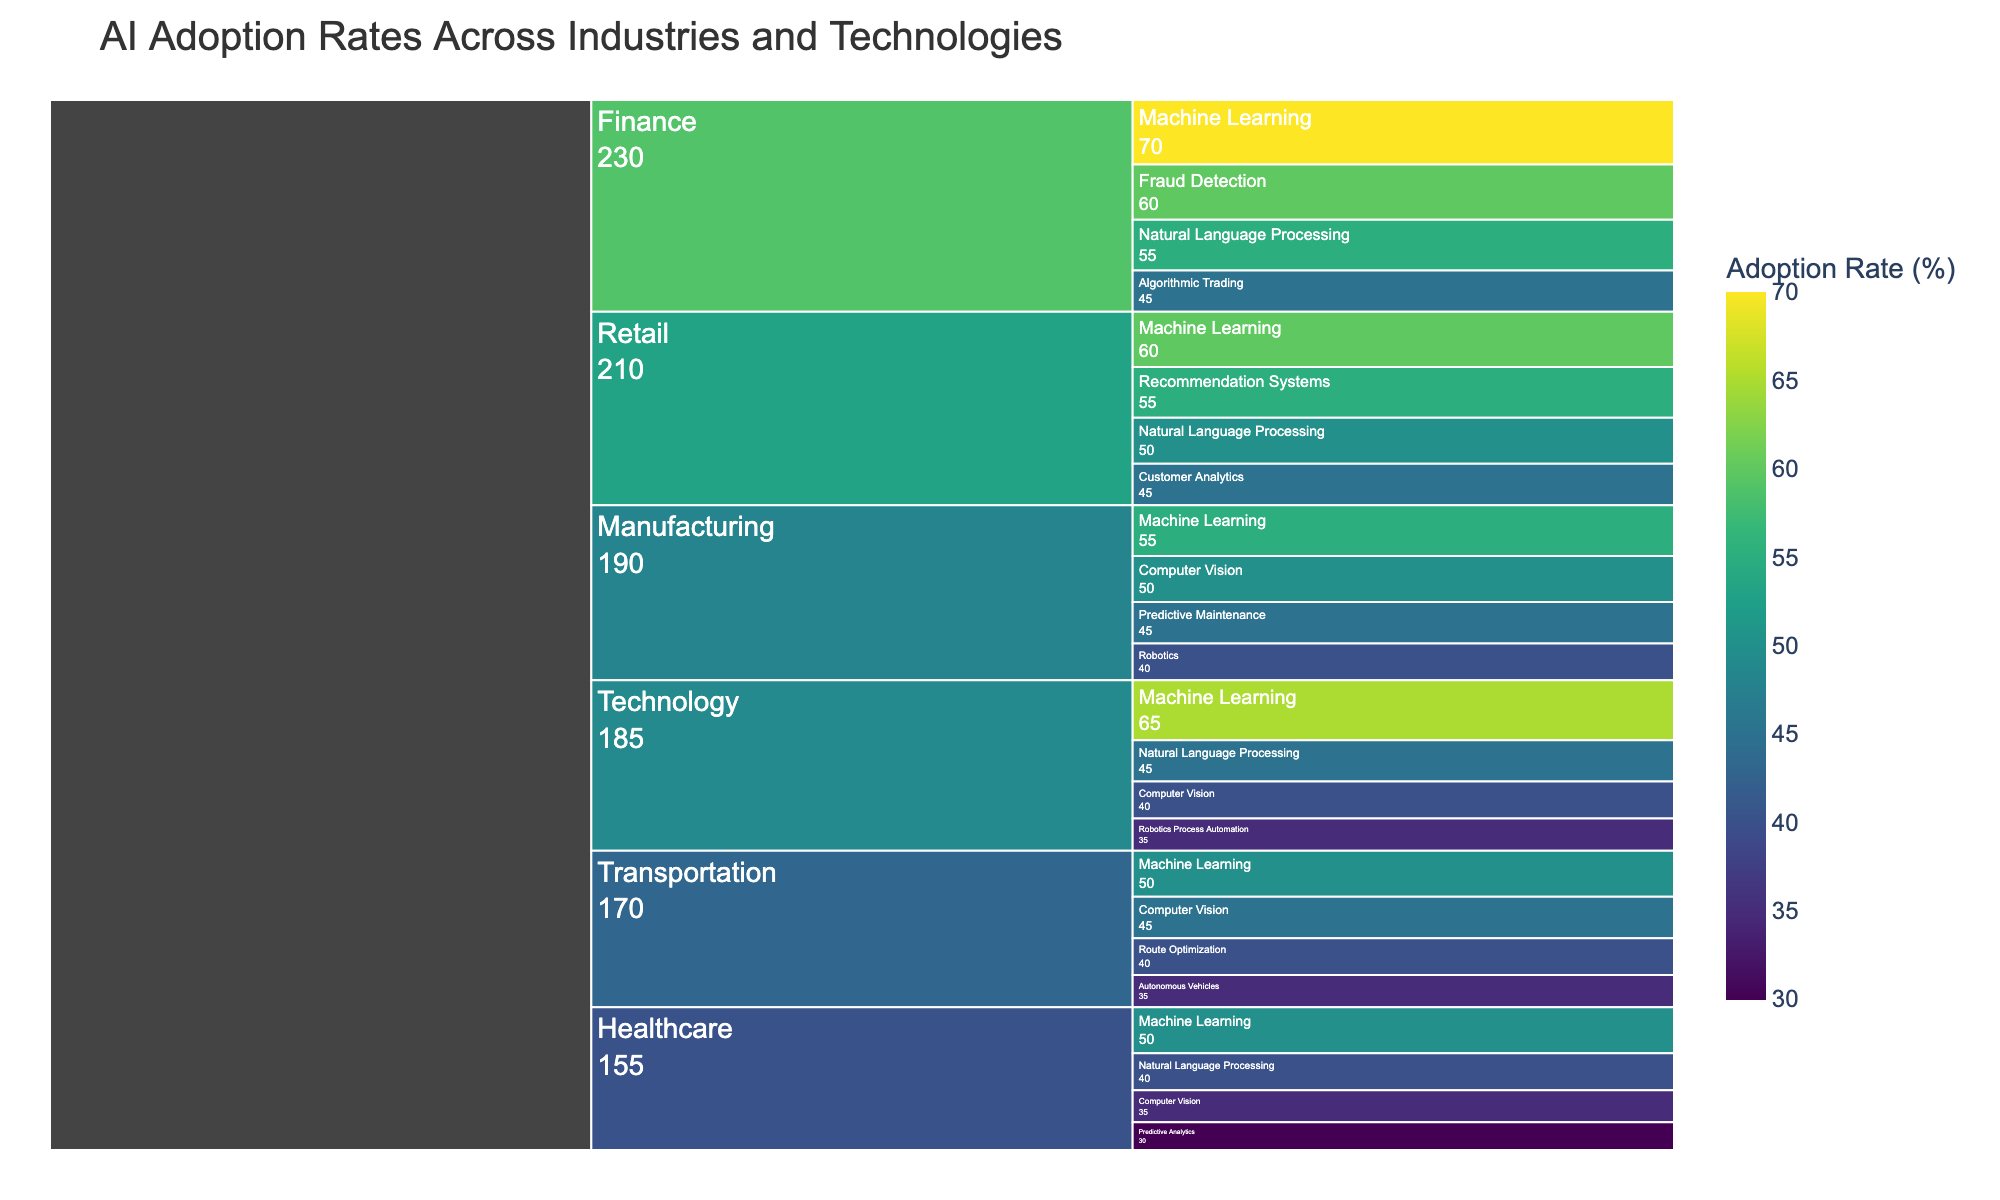What's the title of the chart? The title is located at the top of the figure in large font. It is an overview of what the chart represents.
Answer: AI Adoption Rates Across Industries and Technologies Which industry has the highest AI adoption rate for Machine Learning? Look for the highest percentage value under the Machine Learning section. Identify the corresponding industry.
Answer: Finance What is the overall adoption rate difference between Natural Language Processing in Technology and Healthcare? Find the values for Natural Language Processing in both Technology and Healthcare. Calculate the difference (45 - 40).
Answer: 5% Is the adoption rate of Computer Vision in Manufacturing greater than in Transportation? Compare the adoption rates of Computer Vision in Manufacturing (50) and Transportation (45). Determine if the first is greater.
Answer: Yes Which technology has the lowest adoption rate within the Healthcare industry? Among Machine Learning, Natural Language Processing, Computer Vision, and Predictive Analytics in Healthcare, find the lowest rate.
Answer: Predictive Analytics What's the average AI adoption rate for technologies in the Technology industry? Identify all the values in the Technology industry (65, 45, 40, 35). Calculate the average (sum divided by the number of values). \( (65 + 45 + 40 + 35)/4 = 185/4 = 46.25 \)
Answer: 46.25% How does the adoption rate of Robotics Process Automation in Technology compare to Robotics in Manufacturing? Look at the rates of Robotics Process Automation in Technology (35) and Robotics in Manufacturing (40). Compare the two values.
Answer: Robotics in Manufacturing is higher What’s the color scheme used for the adoption rates in the chart? Observe the gradient or color bar set on the right side of the figure. It shows how colors represent different percentages.
Answer: Viridis Which industry has the most diverse set of AI technologies based on the chart? Identify which industry has the most different AI technologies listed under it.
Answer: Retail Are there more industries that adopt Machine Learning at above or below 55%? Count the instances where Machine Learning adoption rates are above and below 55%. Technology and Finance are above 55%. Healthcare, Manufacturing, and Transportation are at or below 55%.
Answer: Below/Equal 